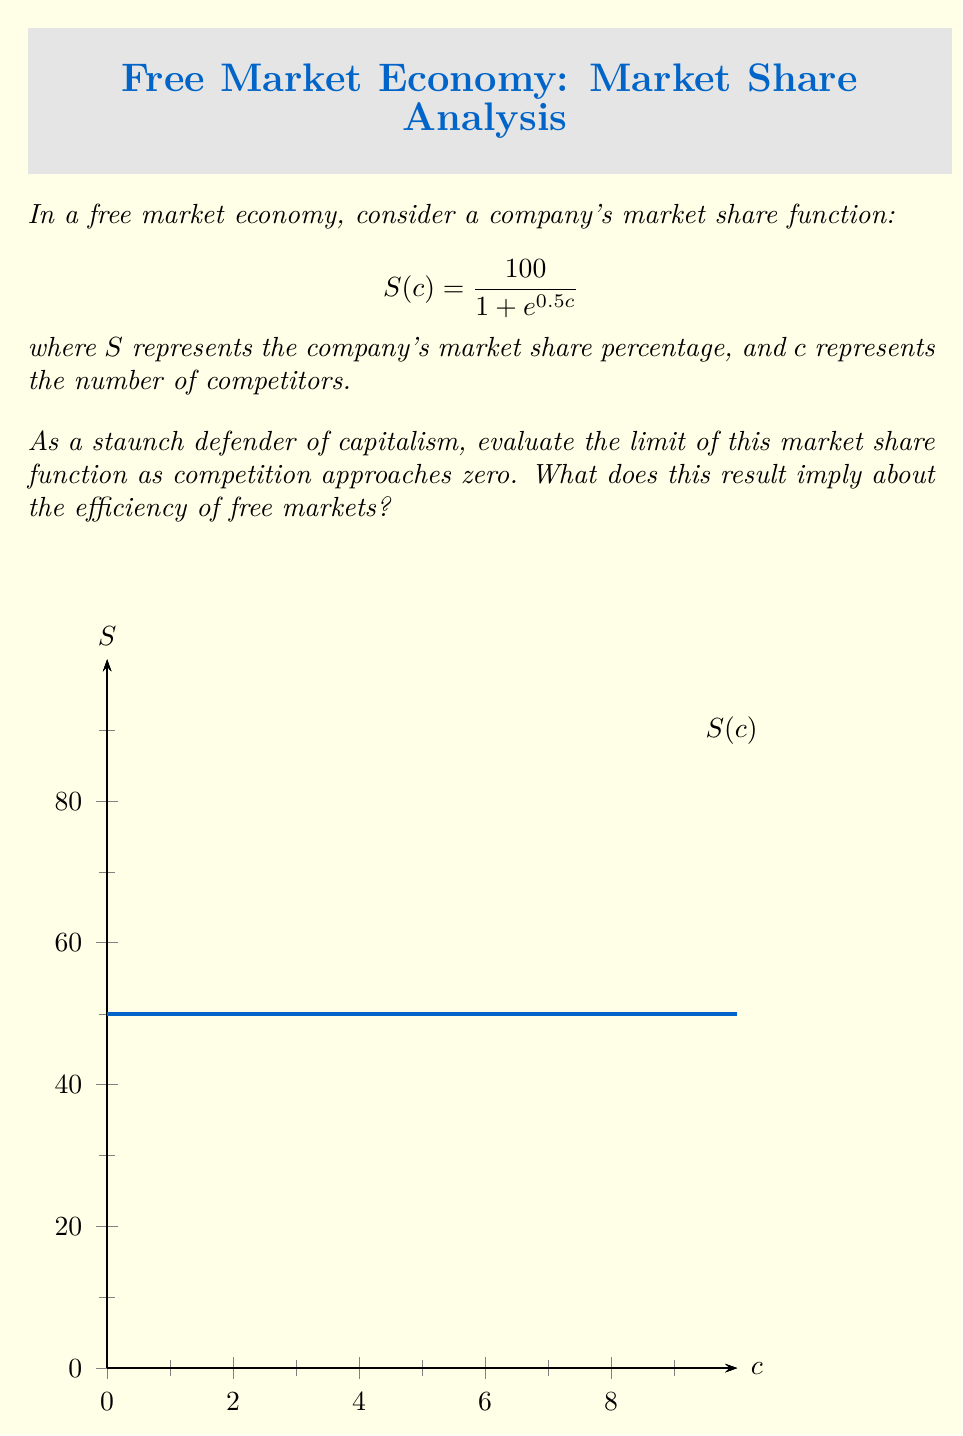Can you solve this math problem? To evaluate this limit, we'll follow these steps:

1) We need to calculate $\lim_{c \to 0} S(c)$, where $S(c) = \frac{100}{1 + e^{0.5c}}$

2) As $c$ approaches 0, $e^{0.5c}$ approaches $e^0 = 1$

3) Substituting this into our function:

   $$\lim_{c \to 0} S(c) = \lim_{c \to 0} \frac{100}{1 + e^{0.5c}} = \frac{100}{1 + 1} = \frac{100}{2} = 50$$

4) Therefore, as competition approaches zero, the company's market share approaches 50%.

5) From a capitalist perspective, this result demonstrates that even in a near-monopoly situation (as competition approaches zero), the market still maintains some level of efficiency. The company doesn't automatically gain 100% market share, suggesting that there are still forces at play (such as potential competition, consumer choice, or government regulation) that prevent complete market domination.

6) This outcome aligns with the capitalist view that free markets tend towards efficiency, as even with minimal competition, a single company cannot capture the entire market.
Answer: 50% 